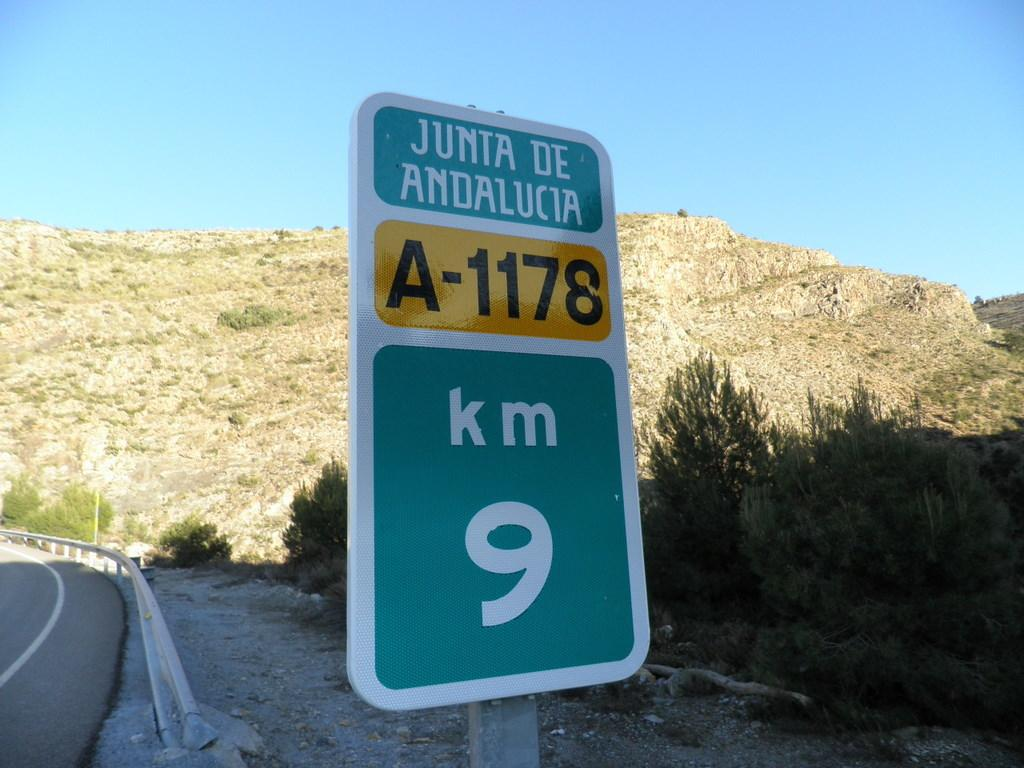Provide a one-sentence caption for the provided image. A 9 Km road sign for Junta De Andalucia. 